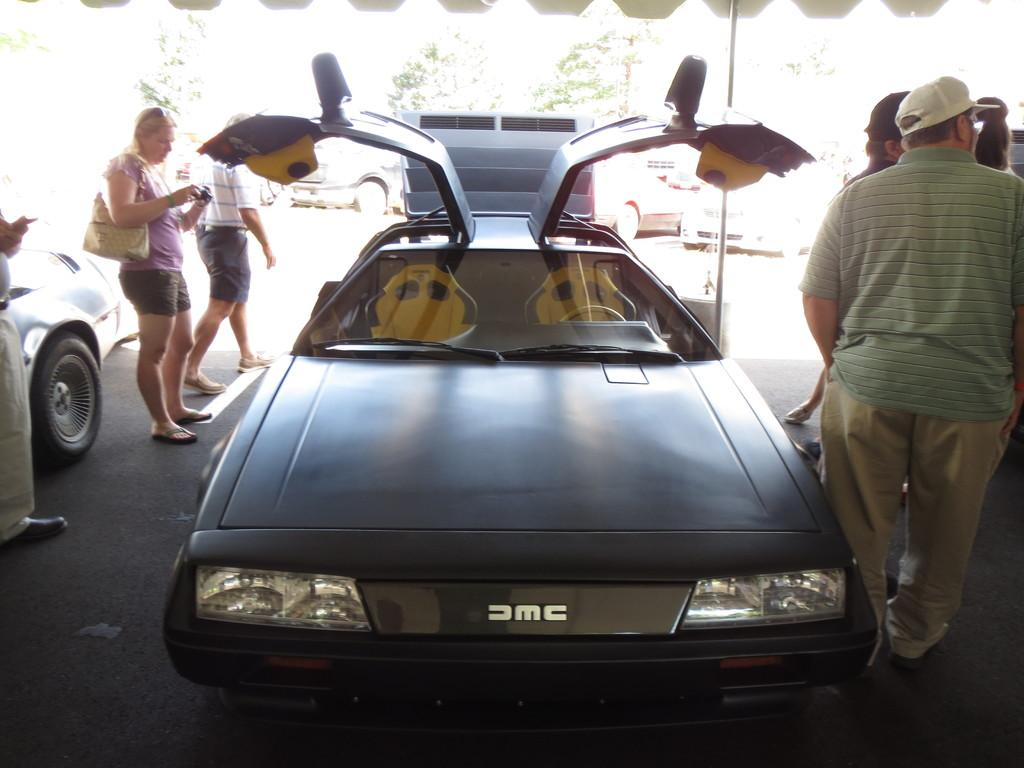What types of objects are present in the image? There are vehicles in the image. What are the people in the image doing? There are people standing and walking in the image. What can be seen in the background of the image? There are trees and parked vehicles in the background of the image. What type of gun is being used by the minister in the image? There is no minister or gun present in the image. 